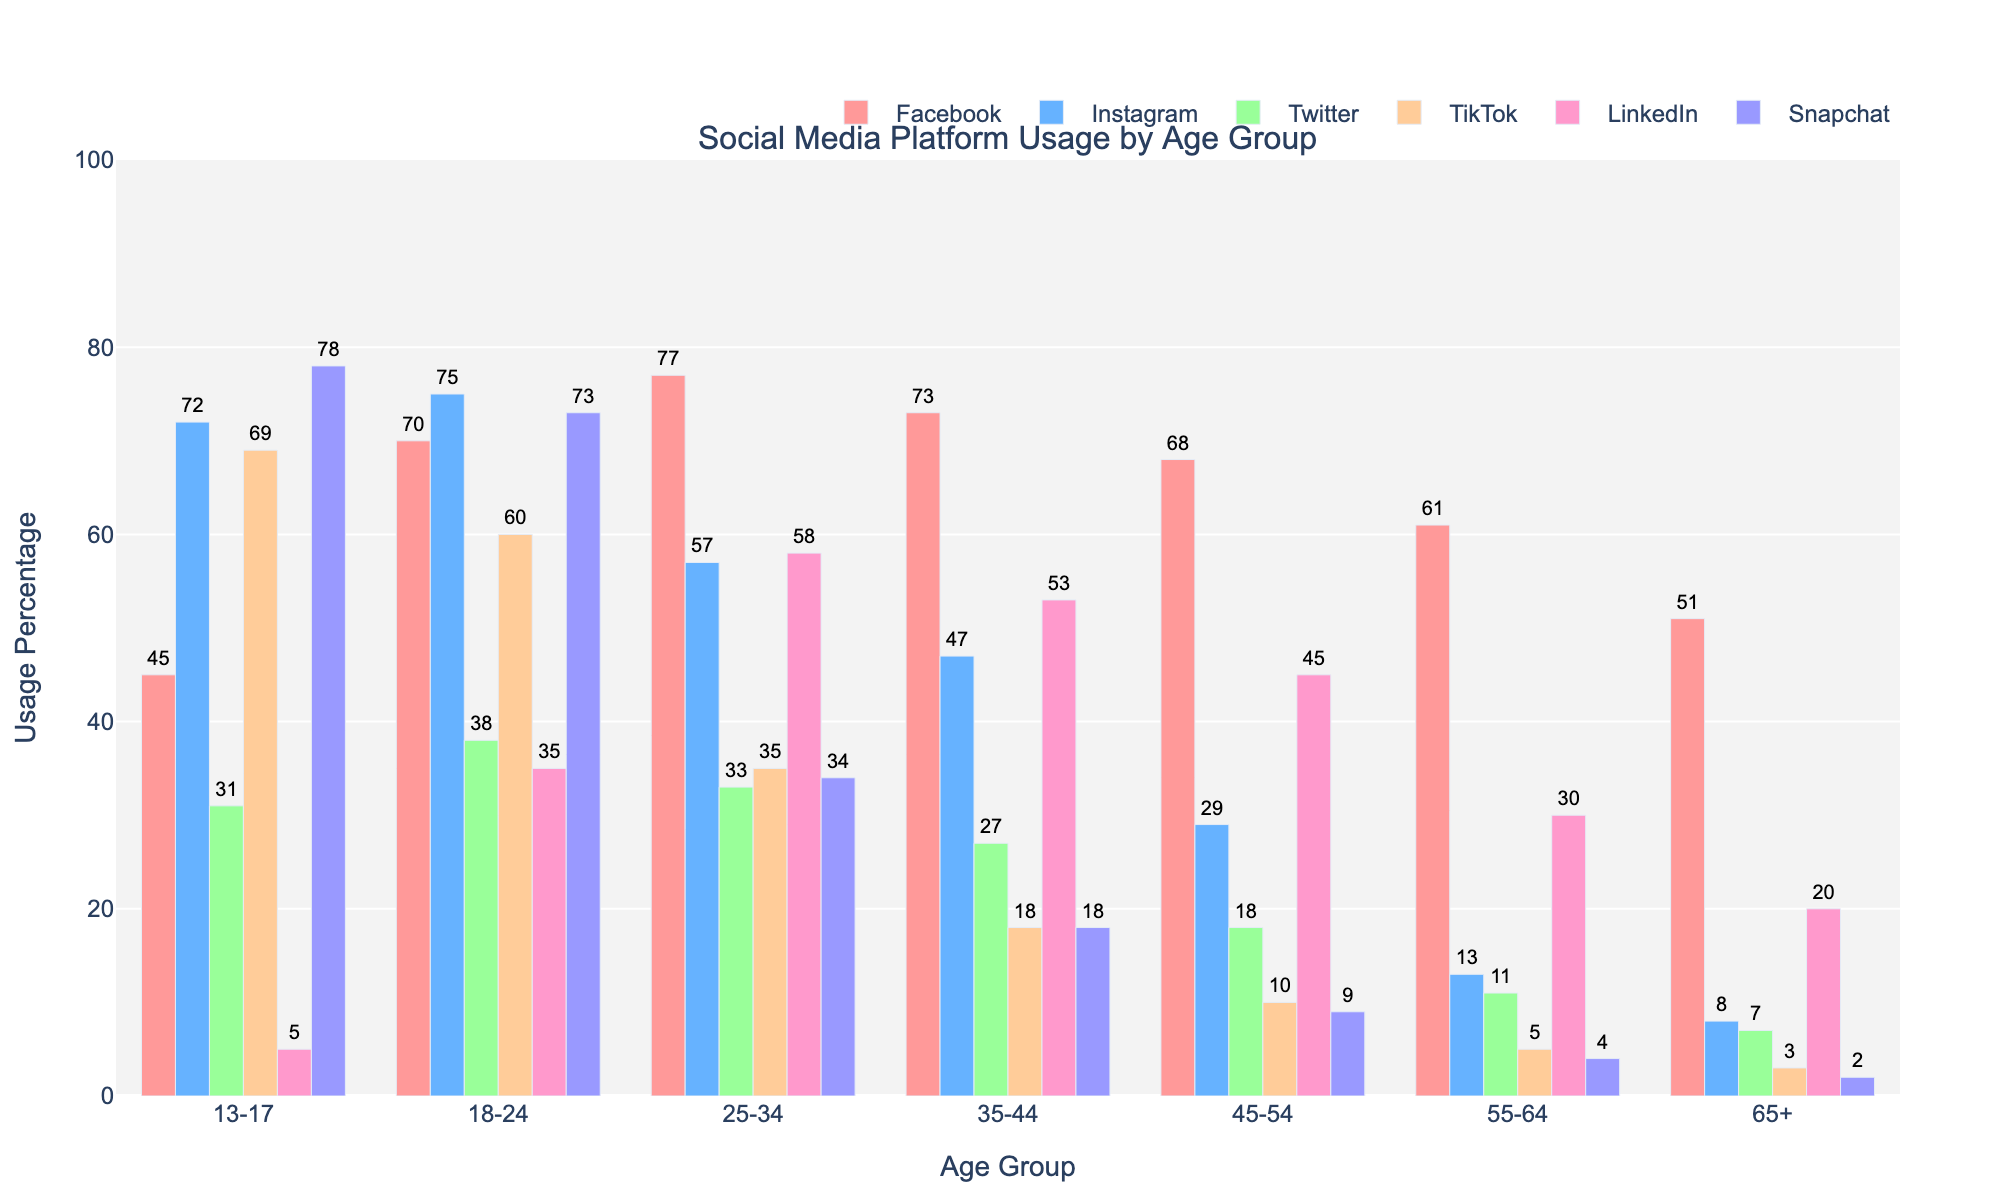Which age group has the highest percentage of Instagram usage? By looking at the height of the bars representing Instagram usage, it is clear that the 18-24 age group has the highest percentage.
Answer: 18-24 How does the Twitter usage of the 25-34 age group compare to that of the 55-64 age group? The Twitter usage for the 25-34 age group is 33%, while it is 11% for the 55-64 age group. Comparing these values, the 25-34 age group uses Twitter 22% more than the 55-64 age group.
Answer: 22% more What is the total percentage of social media usage (Facebook, Instagram, Twitter, TikTok, LinkedIn, Snapchat) for the 13-17 age group? Adding the percentages for Facebook (45), Instagram (72), Twitter (31), TikTok (69), LinkedIn (5), and Snapchat (78), we get a total of 300%.
Answer: 300% Is the Snapchat usage percentage higher among 13-17 year-olds or 25-34 year-olds? The Snapchat usage for the 13-17 age group is 78%, and for the 25-34 age group, it is 34%. Clearly, Snapchat usage is higher among 13-17 year-olds.
Answer: 13-17 year-olds What is the average Facebook usage across all age groups? Summing the Facebook usage percentages for all age groups and dividing by the number of age groups: (45 + 70 + 77 + 73 + 68 + 61 + 51) / 7 = 63.571.
Answer: 63.57% Which age group has a LinkedIn usage percentage closest to the overall median LinkedIn usage among all age groups? Calculating the LinkedIn usage percentages: 5, 35, 58, 53, 45, 30, 20. The median value is the fourth value when sorted numerically: 35, 5, 20, 30, 35, 45, 53, 58, so it's 35, and the age group with LinkedIn usage closest to 35% is 18-24.
Answer: 18-24 How much higher is Instagram usage among 18-24 year-olds compared to 35-44 year-olds? Instagram usage among 18-24 year-olds is 75%, while it is 47% among 35-44 year-olds. The difference is 75 - 47 = 28%.
Answer: 28% higher What is the total Snapchat usage percentage across all age groups combined? Summing the Snapchat usage percentages for all age groups: 78 + 73 + 34 + 18 + 9 + 4 + 2 = 218%.
Answer: 218% Which platform has a consistent decline in usage percentage as age groups increase? Observing the bar heights for each platform across increasing age groups, Twitter shows a consistent decline in usage percentage: 31, 38, 33, 27, 18, 11, 7.
Answer: Twitter 